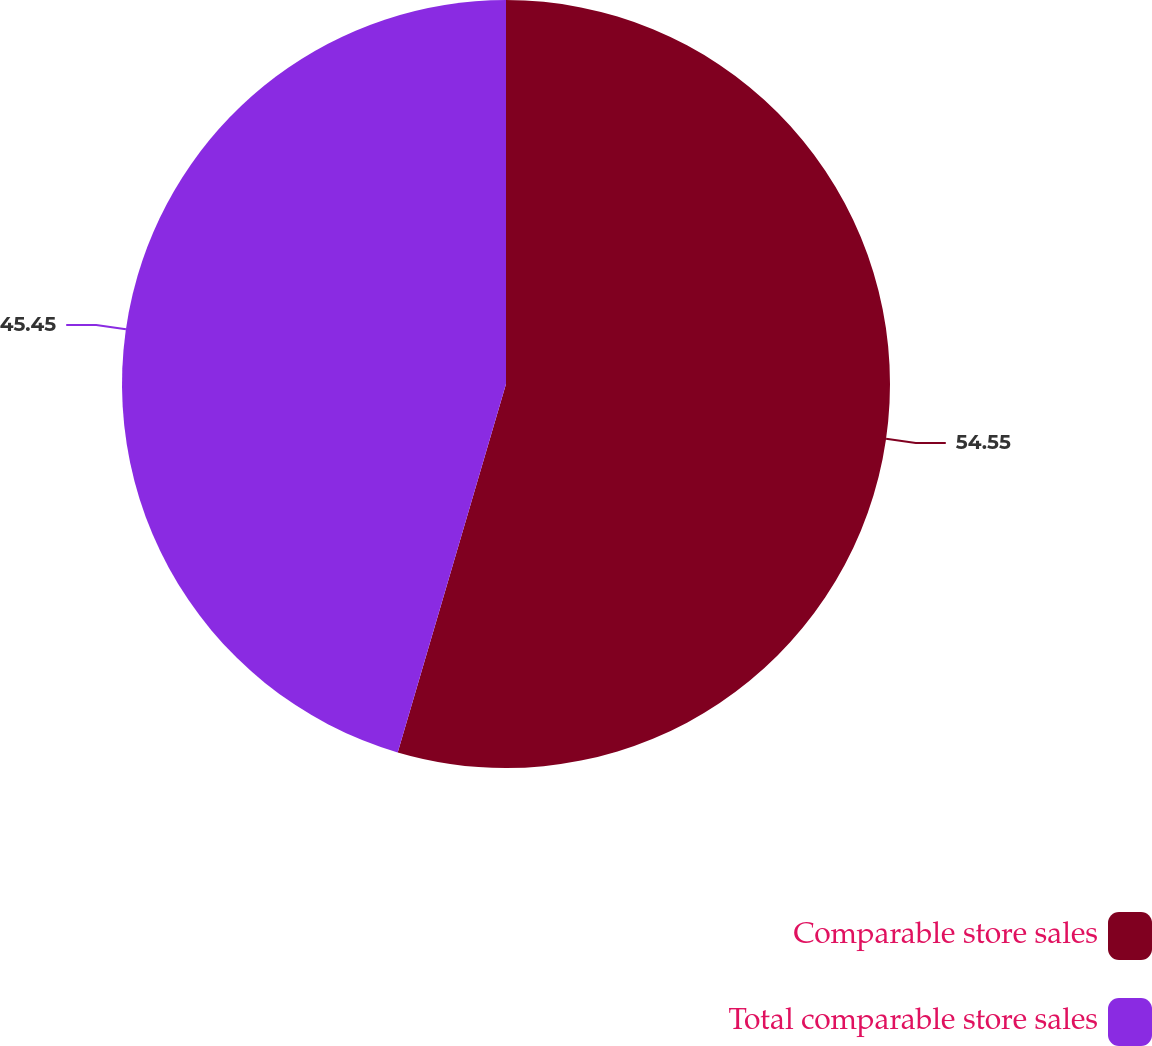Convert chart to OTSL. <chart><loc_0><loc_0><loc_500><loc_500><pie_chart><fcel>Comparable store sales<fcel>Total comparable store sales<nl><fcel>54.55%<fcel>45.45%<nl></chart> 